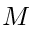Convert formula to latex. <formula><loc_0><loc_0><loc_500><loc_500>M</formula> 